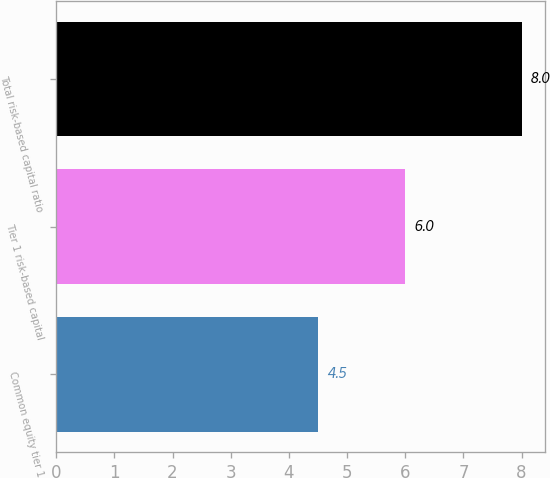<chart> <loc_0><loc_0><loc_500><loc_500><bar_chart><fcel>Common equity tier 1<fcel>Tier 1 risk-based capital<fcel>Total risk-based capital ratio<nl><fcel>4.5<fcel>6<fcel>8<nl></chart> 